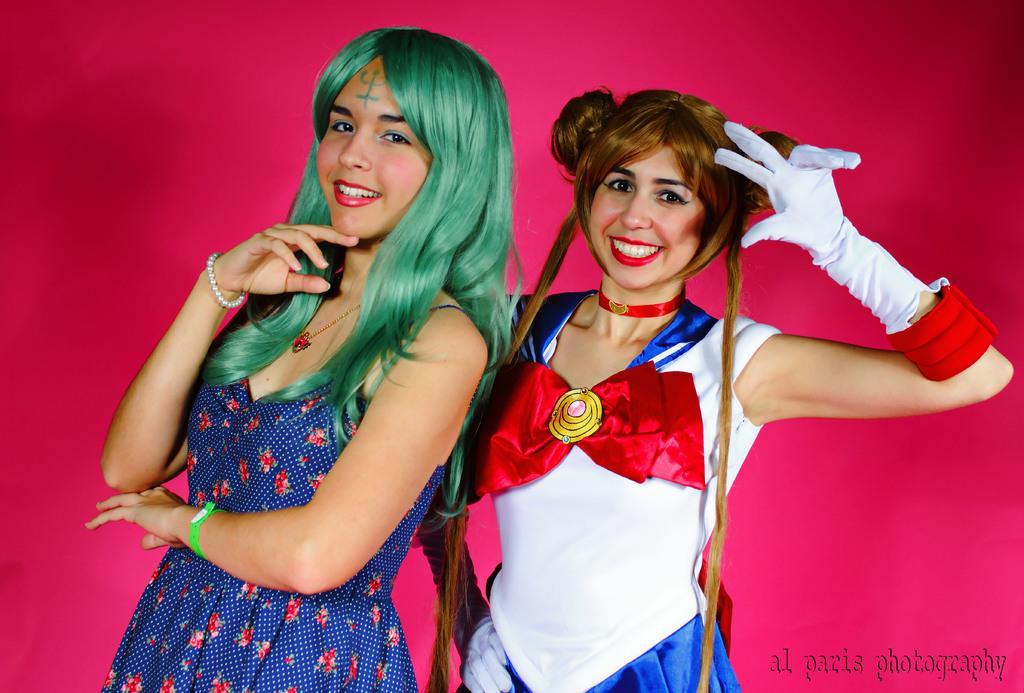Describe this image in one or two sentences. This image consists of two persons. They are women. There are wearing different dresses. One of them is wearing gloves. 